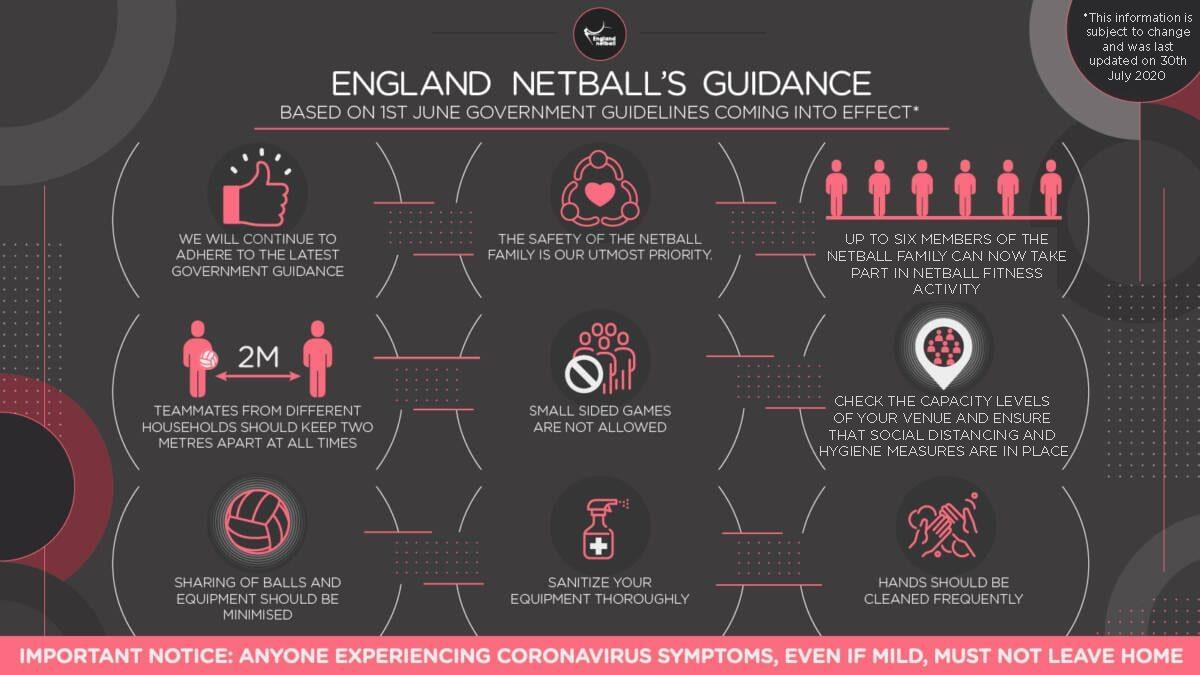Outline some significant characteristics in this image. It is important to follow the latest government guidance in order to ensure compliance. Small-sided games are not allowed according to the latest guidance. Frequent cleaning of hands is necessary. It is essential to maintain a distance of two meters from teammates at all times, The maximum number of members who can participate in a fitness activity is six. 